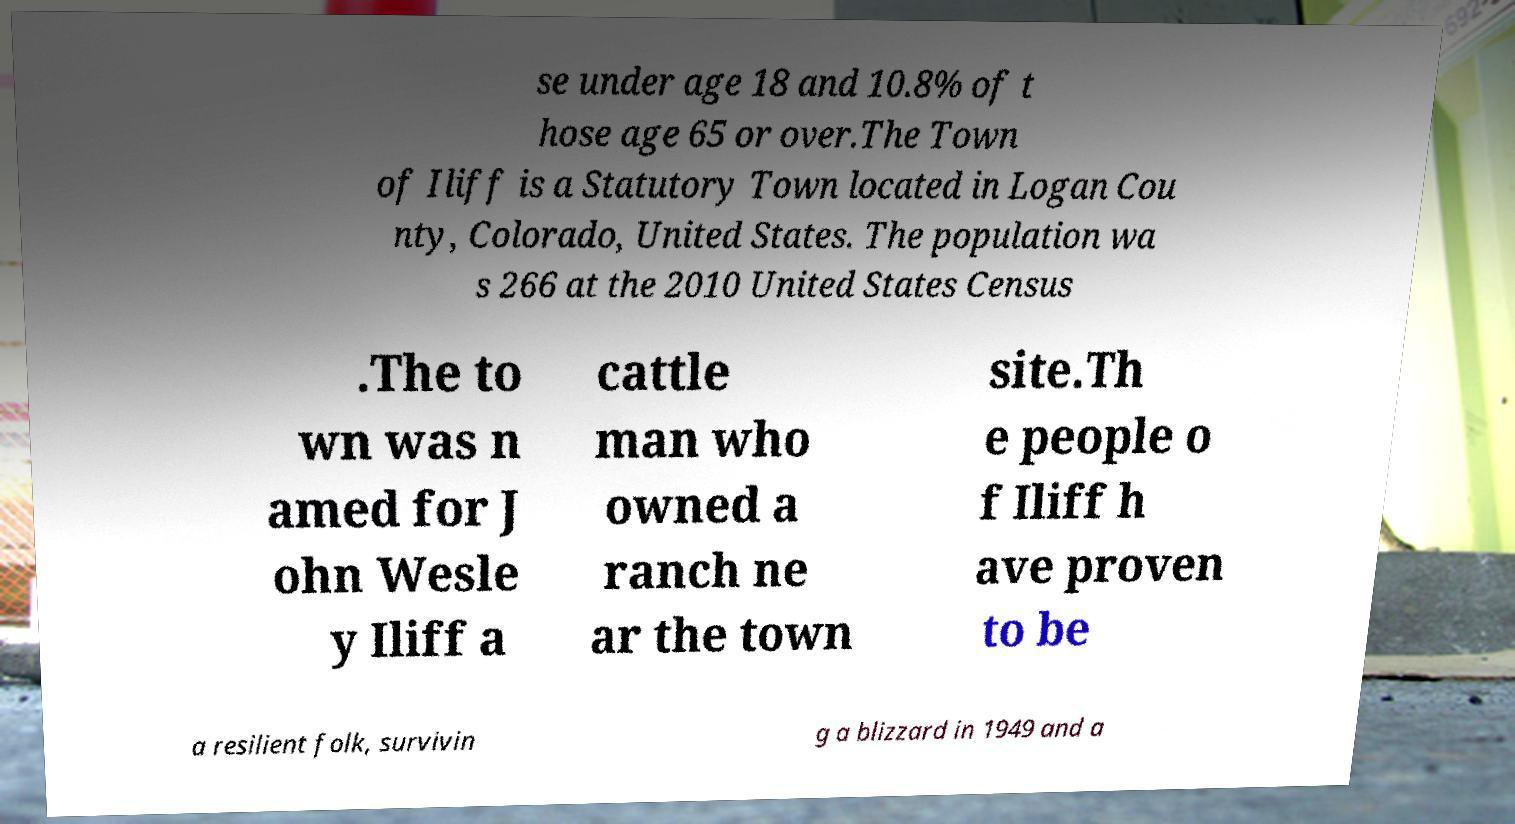Could you extract and type out the text from this image? se under age 18 and 10.8% of t hose age 65 or over.The Town of Iliff is a Statutory Town located in Logan Cou nty, Colorado, United States. The population wa s 266 at the 2010 United States Census .The to wn was n amed for J ohn Wesle y Iliff a cattle man who owned a ranch ne ar the town site.Th e people o f Iliff h ave proven to be a resilient folk, survivin g a blizzard in 1949 and a 